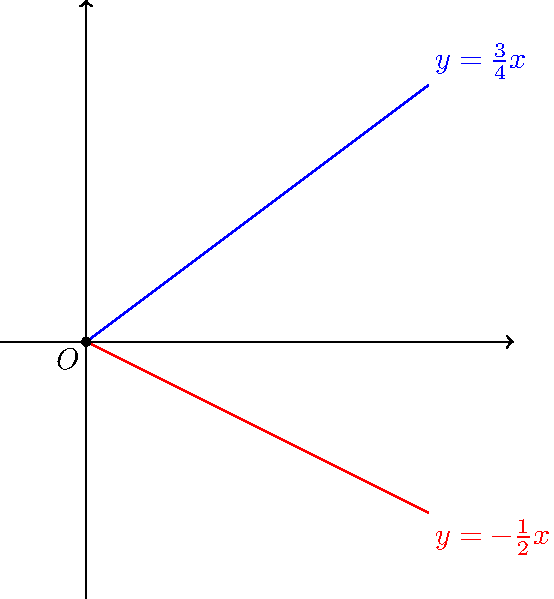As a conference coordinator planning a personal development seminar on work-life harmony, you want to illustrate the concept of finding balance between different aspects of life. You decide to use a geometric analogy. Consider two lines representing "work" and "life" given by the equations $y=\frac{3}{4}x$ and $y=-\frac{1}{2}x$ respectively. Calculate the angle between these two lines to demonstrate the importance of maintaining a healthy work-life angle. Round your answer to the nearest degree. To find the angle between two lines given their equations in slope-intercept form, we can follow these steps:

1) The general formula for the angle $\theta$ between two lines with slopes $m_1$ and $m_2$ is:

   $$\tan \theta = \left|\frac{m_1 - m_2}{1 + m_1m_2}\right|$$

2) From the given equations:
   Line 1 (work): $y=\frac{3}{4}x$, so $m_1 = \frac{3}{4}$
   Line 2 (life): $y=-\frac{1}{2}x$, so $m_2 = -\frac{1}{2}$

3) Substituting these values into the formula:

   $$\tan \theta = \left|\frac{\frac{3}{4} - (-\frac{1}{2})}{1 + \frac{3}{4}(-\frac{1}{2})}\right|$$

4) Simplify the numerator and denominator:

   $$\tan \theta = \left|\frac{\frac{3}{4} + \frac{1}{2}}{1 - \frac{3}{8}}\right| = \left|\frac{\frac{5}{4}}{\frac{5}{8}}\right| = \frac{5}{4} \cdot \frac{8}{5} = 2$$

5) Now we need to find the angle whose tangent is 2:

   $$\theta = \arctan(2)$$

6) Using a calculator or trigonometric tables:

   $$\theta \approx 63.43^\circ$$

7) Rounding to the nearest degree:

   $$\theta \approx 63^\circ$$

This angle represents the "work-life angle" in our analogy, demonstrating the importance of maintaining a balance between work and personal life.
Answer: 63° 